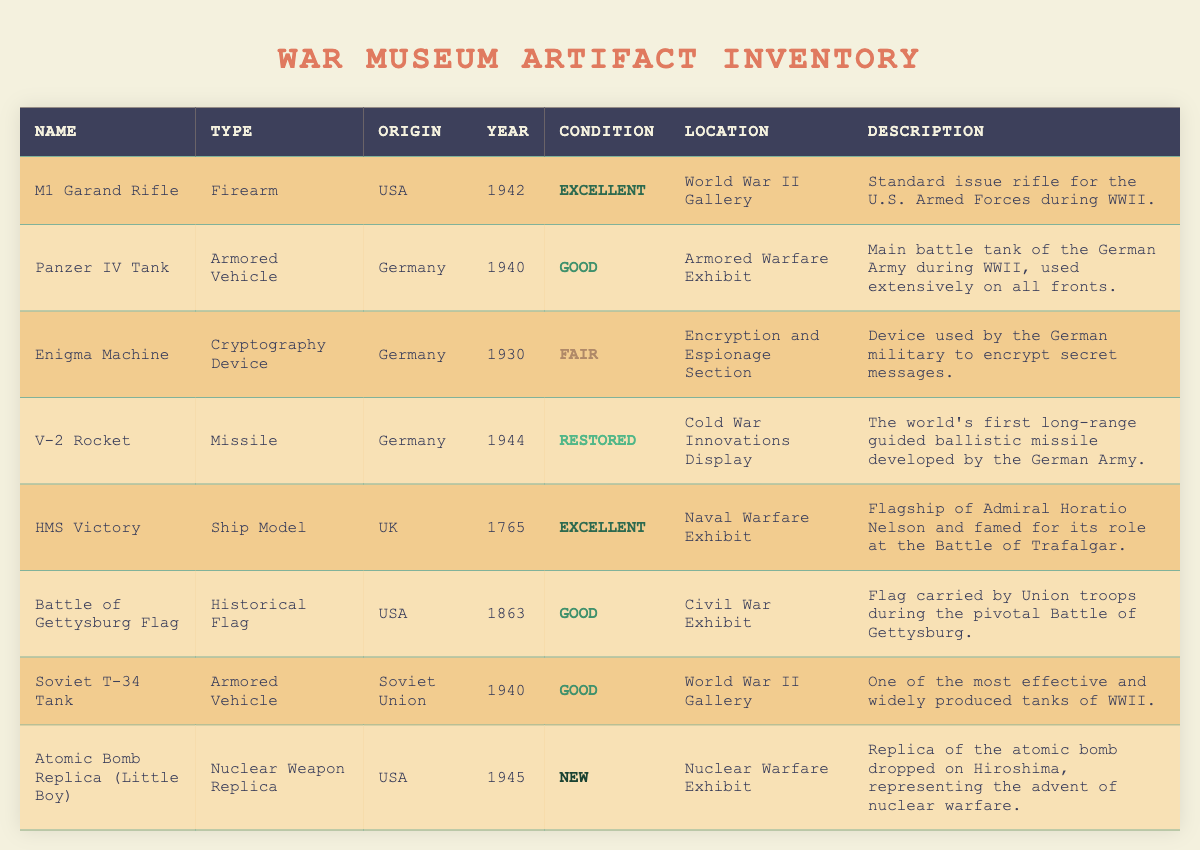What is the type of the M1 Garand Rifle? The type of the M1 Garand Rifle is listed in the "Type" column of the table. For the entry corresponding to the M1 Garand Rifle, the type is "Firearm."
Answer: Firearm In which year was the V-2 Rocket developed? The year of development for the V-2 Rocket can be found in the "Year" column for the respective entry. According to the table, it was developed in 1944.
Answer: 1944 How many artifacts in the inventory are marked as "Good" condition? To find this, we count the entries in the "Condition" column that are labeled as "Good." There are three such entries: the Panzer IV Tank, the Battle of Gettysburg Flag, and the Soviet T-34 Tank. Therefore, the count is 3.
Answer: 3 Is the Enigma Machine in excellent condition? The condition of the Enigma Machine can be found in its respective row under the "Condition" column. It is listed as "Fair," meaning it is not in excellent condition.
Answer: No What is the average year of the artifacts in the inventory? To calculate the average year, first, we sum the years of all artifacts: 1942 + 1940 + 1930 + 1944 + 1765 + 1863 + 1940 + 1945 =  1459. Next, we divide by the total number of artifacts, which is 8: 1459 / 8 = 182.375. Rounding gives us an approximate average year of 1824.
Answer: 1824 What are the origins of the artifacts located in the World War II Gallery? To answer this, we check the "Location" column for entries marked as "World War II Gallery." The M1 Garand Rifle and the Soviet T-34 Tank are found in this location. Their origins are USA and Soviet Union, respectively.
Answer: USA and Soviet Union Which artifact has the oldest year of origin? We look through the "Year" column to find the oldest entry. The HMS Victory has the year 1765, which is earlier than any other artifact. Thus, it has the oldest year of origin in the inventory.
Answer: 1765 How many different types of artifacts are on display in the museum? To determine the number of different types, we can look at the "Type" column and count unique entries. The unique types are Firearm, Armored Vehicle, Cryptography Device, Missile, Ship Model, Historical Flag, and Nuclear Weapon Replica, which totals 7 different types.
Answer: 7 Is the condition of the Atomic Bomb Replica (Little Boy) classified as "Restored"? We check the "Condition" column for the Atomic Bomb Replica (Little Boy). It is labeled as "New," so it is not marked as "Restored."
Answer: No 